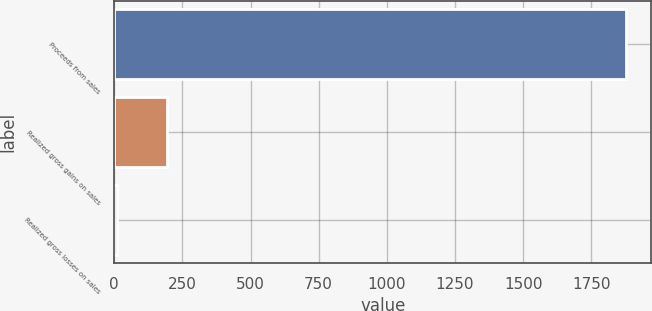Convert chart. <chart><loc_0><loc_0><loc_500><loc_500><bar_chart><fcel>Proceeds from sales<fcel>Realized gross gains on sales<fcel>Realized gross losses on sales<nl><fcel>1876.4<fcel>195.47<fcel>8.7<nl></chart> 